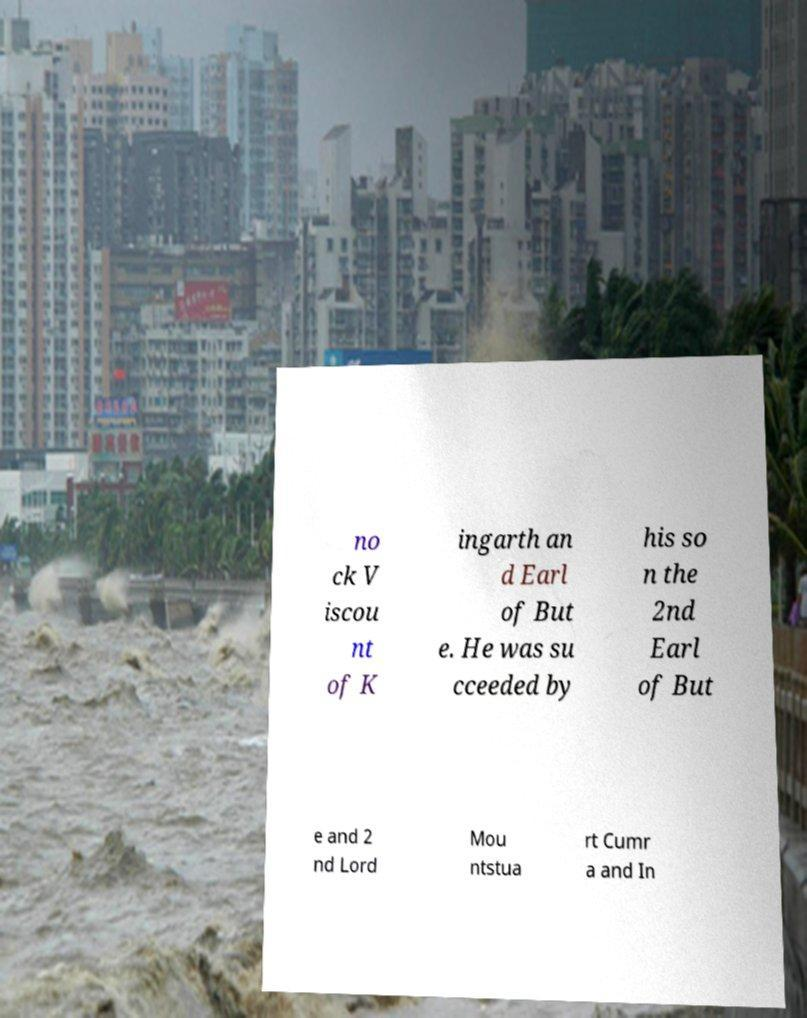Please read and relay the text visible in this image. What does it say? no ck V iscou nt of K ingarth an d Earl of But e. He was su cceeded by his so n the 2nd Earl of But e and 2 nd Lord Mou ntstua rt Cumr a and In 